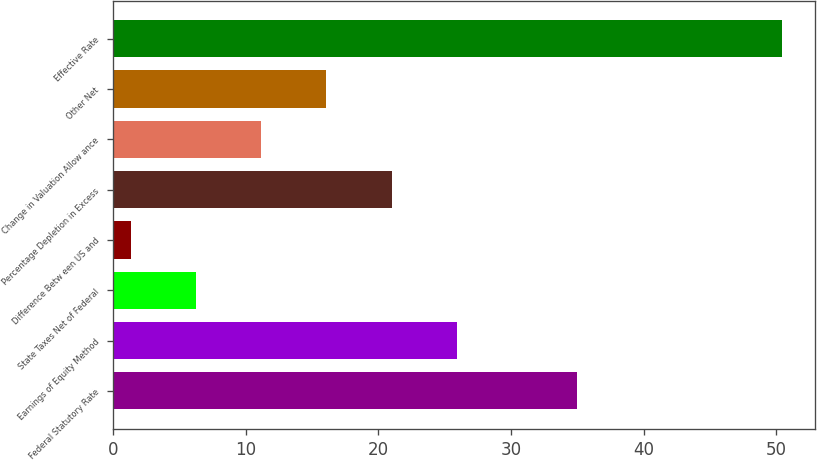<chart> <loc_0><loc_0><loc_500><loc_500><bar_chart><fcel>Federal Statutory Rate<fcel>Earnings of Equity Method<fcel>State Taxes Net of Federal<fcel>Difference Betw een US and<fcel>Percentage Depletion in Excess<fcel>Change in Valuation Allow ance<fcel>Other Net<fcel>Effective Rate<nl><fcel>35<fcel>25.9<fcel>6.3<fcel>1.4<fcel>21<fcel>11.2<fcel>16.1<fcel>50.4<nl></chart> 